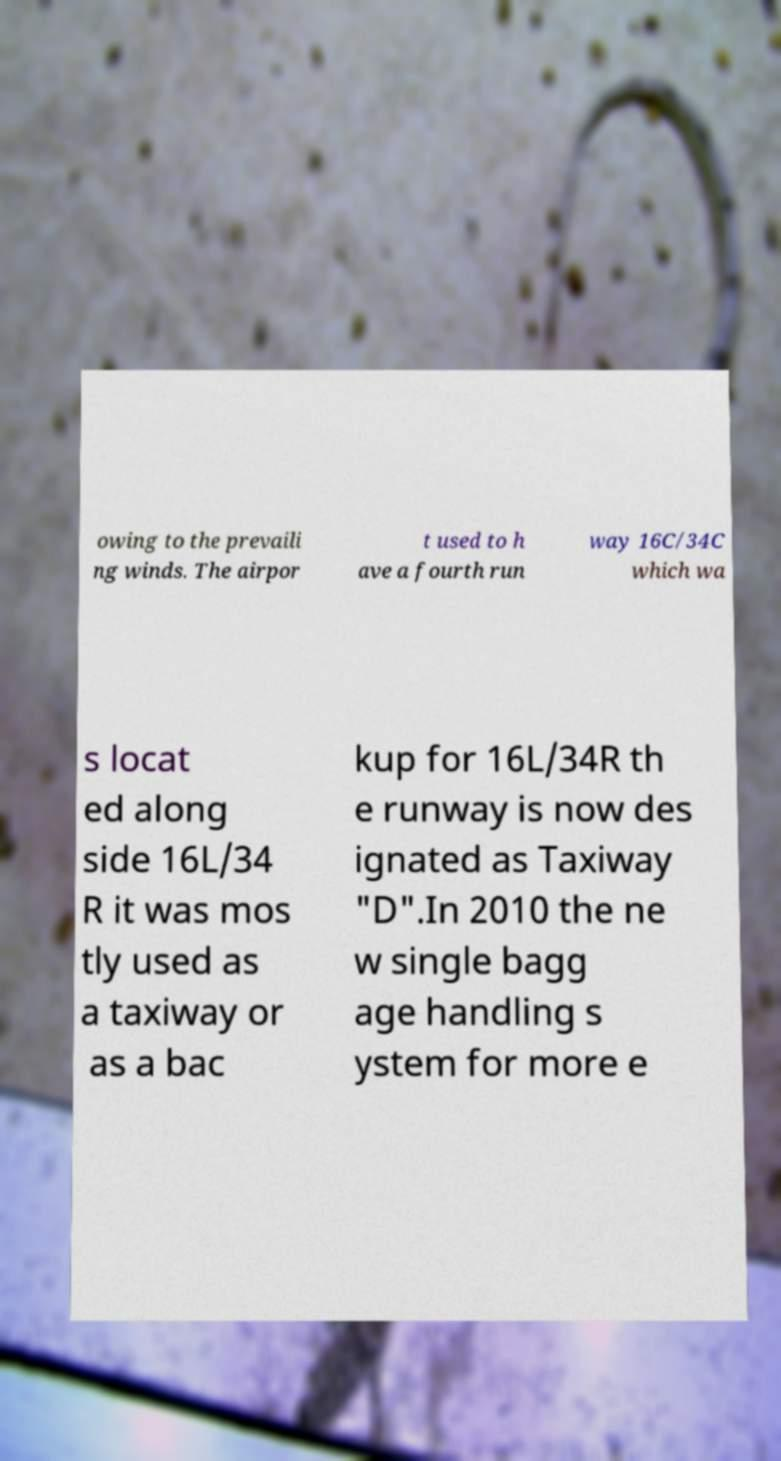Could you extract and type out the text from this image? owing to the prevaili ng winds. The airpor t used to h ave a fourth run way 16C/34C which wa s locat ed along side 16L/34 R it was mos tly used as a taxiway or as a bac kup for 16L/34R th e runway is now des ignated as Taxiway "D".In 2010 the ne w single bagg age handling s ystem for more e 